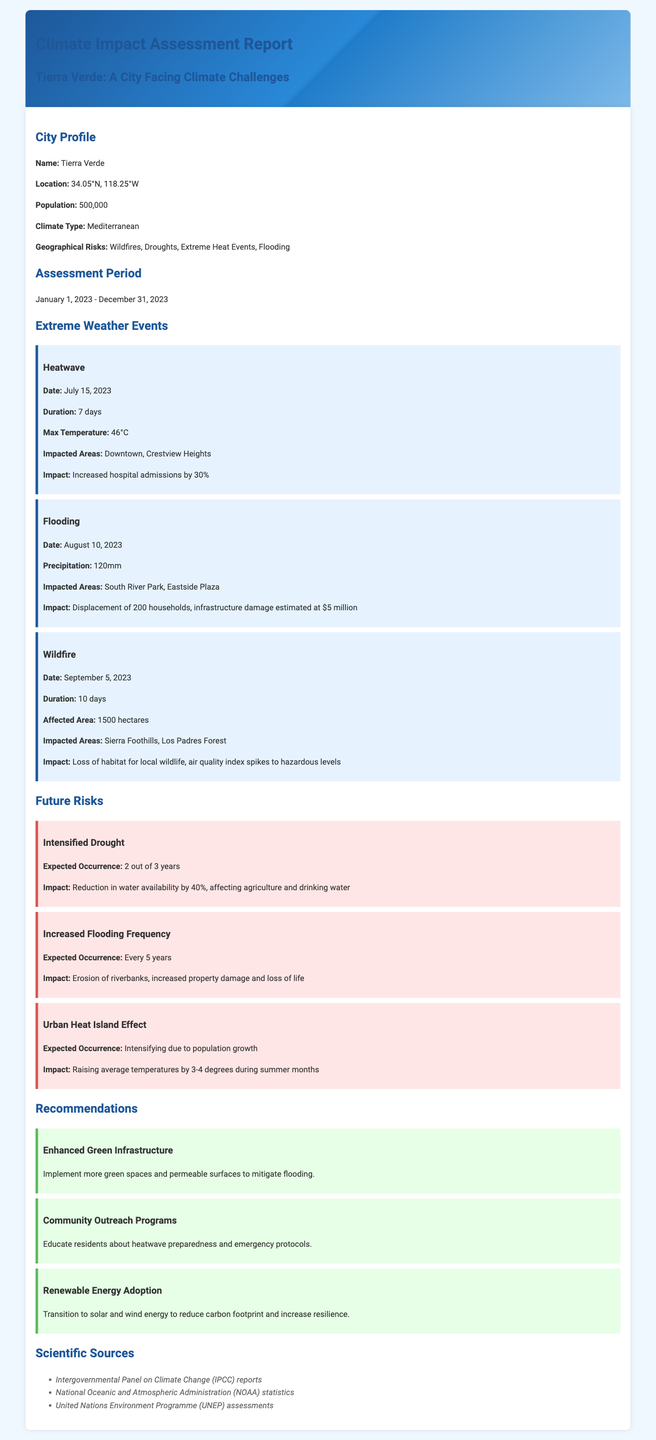what is the population of Tierra Verde? The population of Tierra Verde is stated in the City Profile section of the document.
Answer: 500,000 what event occurred on July 15, 2023? The document lists multiple extreme weather events with specific dates, including the heatwave on July 15, 2023.
Answer: Heatwave what was the maximum temperature recorded during the heatwave? The maximum temperature recorded during the heatwave is provided in the Extreme Weather Events section.
Answer: 46°C how many households were displaced due to flooding? The number of displaced households can be found in the description of the flooding event.
Answer: 200 what is the expected occurrence of intensified drought in Tierra Verde? The expected occurrence for each future risk is listed in the Future Risks section.
Answer: 2 out of 3 years what is one of the recommended actions to mitigate flooding? The recommendations section details various actions, including one specific to mitigating flooding.
Answer: Enhanced Green Infrastructure how many hectares were affected by the wildfire? The impacted area for the wildfire event is specified in the Extreme Weather Events section.
Answer: 1500 hectares what are the potential temperature increases due to the Urban Heat Island Effect? The document discusses the expected impact of the Urban Heat Island Effect in Future Risks.
Answer: 3-4 degrees what is the main climate type of Tierra Verde? The climate type is stated in the City Profile section of the document.
Answer: Mediterranean 